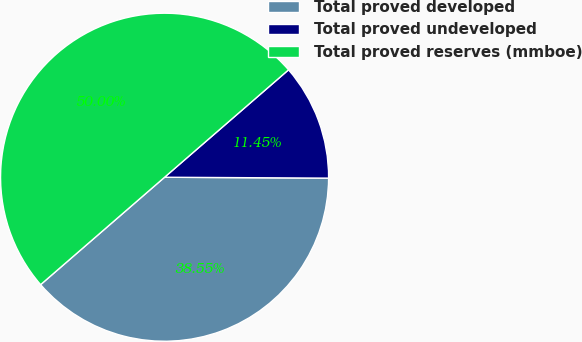<chart> <loc_0><loc_0><loc_500><loc_500><pie_chart><fcel>Total proved developed<fcel>Total proved undeveloped<fcel>Total proved reserves (mmboe)<nl><fcel>38.55%<fcel>11.45%<fcel>50.0%<nl></chart> 